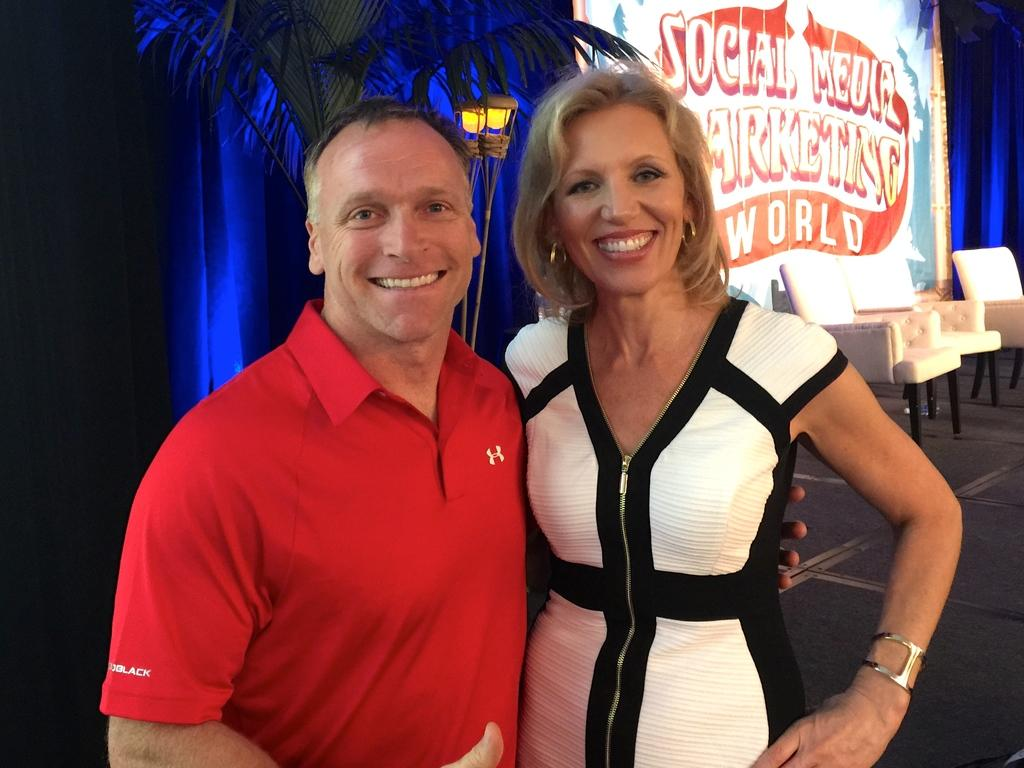<image>
Present a compact description of the photo's key features. A couple stands in front of a sign that says social media on it. 